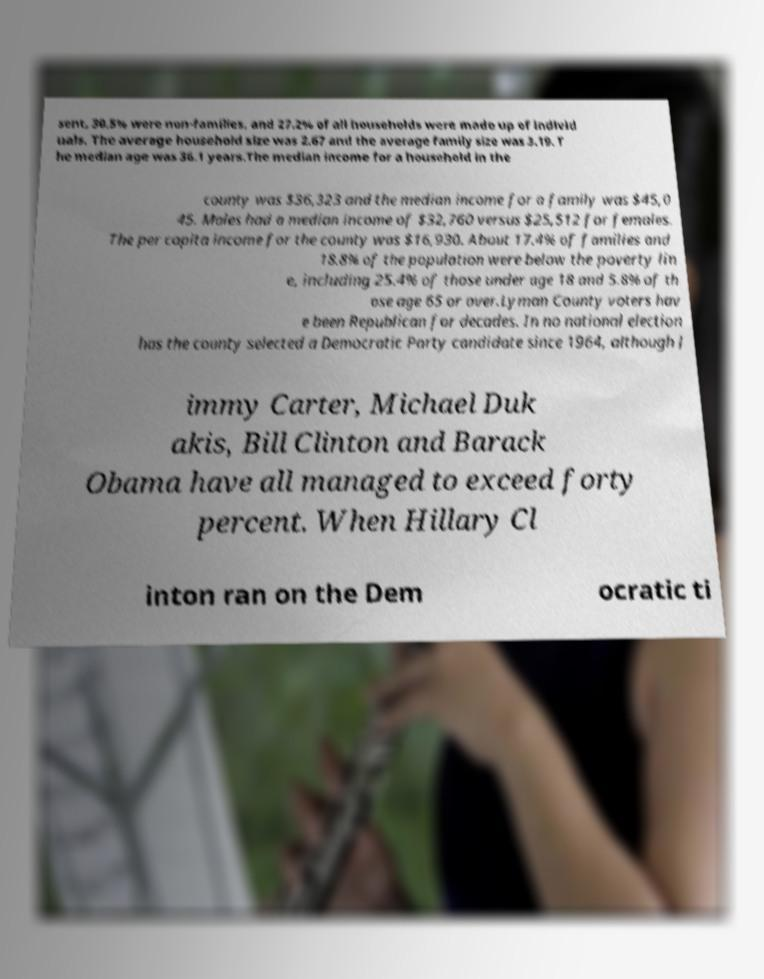Can you read and provide the text displayed in the image?This photo seems to have some interesting text. Can you extract and type it out for me? sent, 30.5% were non-families, and 27.2% of all households were made up of individ uals. The average household size was 2.67 and the average family size was 3.19. T he median age was 36.1 years.The median income for a household in the county was $36,323 and the median income for a family was $45,0 45. Males had a median income of $32,760 versus $25,512 for females. The per capita income for the county was $16,930. About 17.4% of families and 18.8% of the population were below the poverty lin e, including 25.4% of those under age 18 and 5.8% of th ose age 65 or over.Lyman County voters hav e been Republican for decades. In no national election has the county selected a Democratic Party candidate since 1964, although J immy Carter, Michael Duk akis, Bill Clinton and Barack Obama have all managed to exceed forty percent. When Hillary Cl inton ran on the Dem ocratic ti 